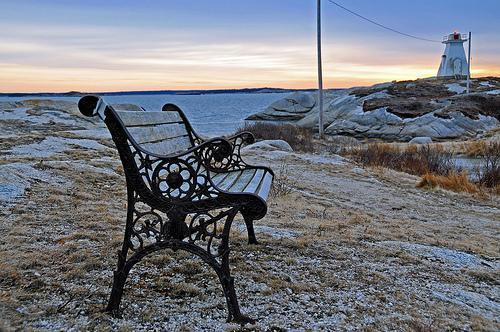How many benches are there?
Give a very brief answer. 1. How many electricity poles are there?
Give a very brief answer. 2. 